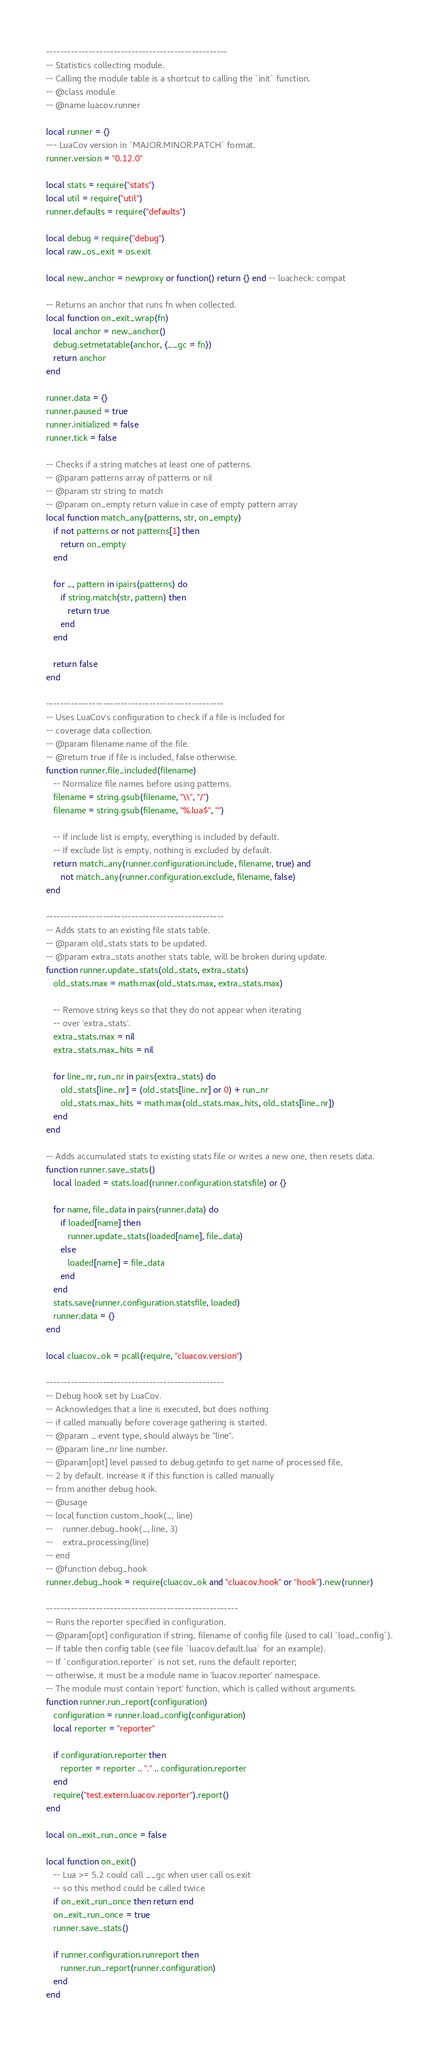Convert code to text. <code><loc_0><loc_0><loc_500><loc_500><_Lua_>---------------------------------------------------
-- Statistics collecting module.
-- Calling the module table is a shortcut to calling the `init` function.
-- @class module
-- @name luacov.runner

local runner = {}
--- LuaCov version in `MAJOR.MINOR.PATCH` format.
runner.version = "0.12.0"

local stats = require("stats")
local util = require("util")
runner.defaults = require("defaults")

local debug = require("debug")
local raw_os_exit = os.exit

local new_anchor = newproxy or function() return {} end -- luacheck: compat

-- Returns an anchor that runs fn when collected.
local function on_exit_wrap(fn)
   local anchor = new_anchor()
   debug.setmetatable(anchor, {__gc = fn})
   return anchor
end

runner.data = {}
runner.paused = true
runner.initialized = false
runner.tick = false

-- Checks if a string matches at least one of patterns.
-- @param patterns array of patterns or nil
-- @param str string to match
-- @param on_empty return value in case of empty pattern array
local function match_any(patterns, str, on_empty)
   if not patterns or not patterns[1] then
      return on_empty
   end

   for _, pattern in ipairs(patterns) do
      if string.match(str, pattern) then
         return true
      end
   end

   return false
end

--------------------------------------------------
-- Uses LuaCov's configuration to check if a file is included for
-- coverage data collection.
-- @param filename name of the file.
-- @return true if file is included, false otherwise.
function runner.file_included(filename)
   -- Normalize file names before using patterns.
   filename = string.gsub(filename, "\\", "/")
   filename = string.gsub(filename, "%.lua$", "")

   -- If include list is empty, everything is included by default.
   -- If exclude list is empty, nothing is excluded by default.
   return match_any(runner.configuration.include, filename, true) and
      not match_any(runner.configuration.exclude, filename, false)
end

--------------------------------------------------
-- Adds stats to an existing file stats table.
-- @param old_stats stats to be updated.
-- @param extra_stats another stats table, will be broken during update.
function runner.update_stats(old_stats, extra_stats)
   old_stats.max = math.max(old_stats.max, extra_stats.max)

   -- Remove string keys so that they do not appear when iterating
   -- over 'extra_stats'.
   extra_stats.max = nil
   extra_stats.max_hits = nil
      
   for line_nr, run_nr in pairs(extra_stats) do
      old_stats[line_nr] = (old_stats[line_nr] or 0) + run_nr
      old_stats.max_hits = math.max(old_stats.max_hits, old_stats[line_nr])
   end
end

-- Adds accumulated stats to existing stats file or writes a new one, then resets data.
function runner.save_stats()
   local loaded = stats.load(runner.configuration.statsfile) or {}

   for name, file_data in pairs(runner.data) do
      if loaded[name] then
         runner.update_stats(loaded[name], file_data)
      else
         loaded[name] = file_data
      end
   end
   stats.save(runner.configuration.statsfile, loaded)
   runner.data = {}
end

local cluacov_ok = pcall(require, "cluacov.version")

--------------------------------------------------
-- Debug hook set by LuaCov.
-- Acknowledges that a line is executed, but does nothing
-- if called manually before coverage gathering is started.
-- @param _ event type, should always be "line".
-- @param line_nr line number.
-- @param[opt] level passed to debug.getinfo to get name of processed file,
-- 2 by default. Increase it if this function is called manually
-- from another debug hook.
-- @usage
-- local function custom_hook(_, line)
--    runner.debug_hook(_, line, 3)
--    extra_processing(line)
-- end
-- @function debug_hook
runner.debug_hook = require(cluacov_ok and "cluacov.hook" or "hook").new(runner)

------------------------------------------------------
-- Runs the reporter specified in configuration.
-- @param[opt] configuration if string, filename of config file (used to call `load_config`).
-- If table then config table (see file `luacov.default.lua` for an example).
-- If `configuration.reporter` is not set, runs the default reporter;
-- otherwise, it must be a module name in 'luacov.reporter' namespace.
-- The module must contain 'report' function, which is called without arguments.
function runner.run_report(configuration)
   configuration = runner.load_config(configuration)
   local reporter = "reporter"

   if configuration.reporter then
      reporter = reporter .. "." .. configuration.reporter
   end
   require("test.extern.luacov.reporter").report()
end

local on_exit_run_once = false

local function on_exit()
   -- Lua >= 5.2 could call __gc when user call os.exit
   -- so this method could be called twice
   if on_exit_run_once then return end
   on_exit_run_once = true
   runner.save_stats()

   if runner.configuration.runreport then
      runner.run_report(runner.configuration)
   end
end
</code> 